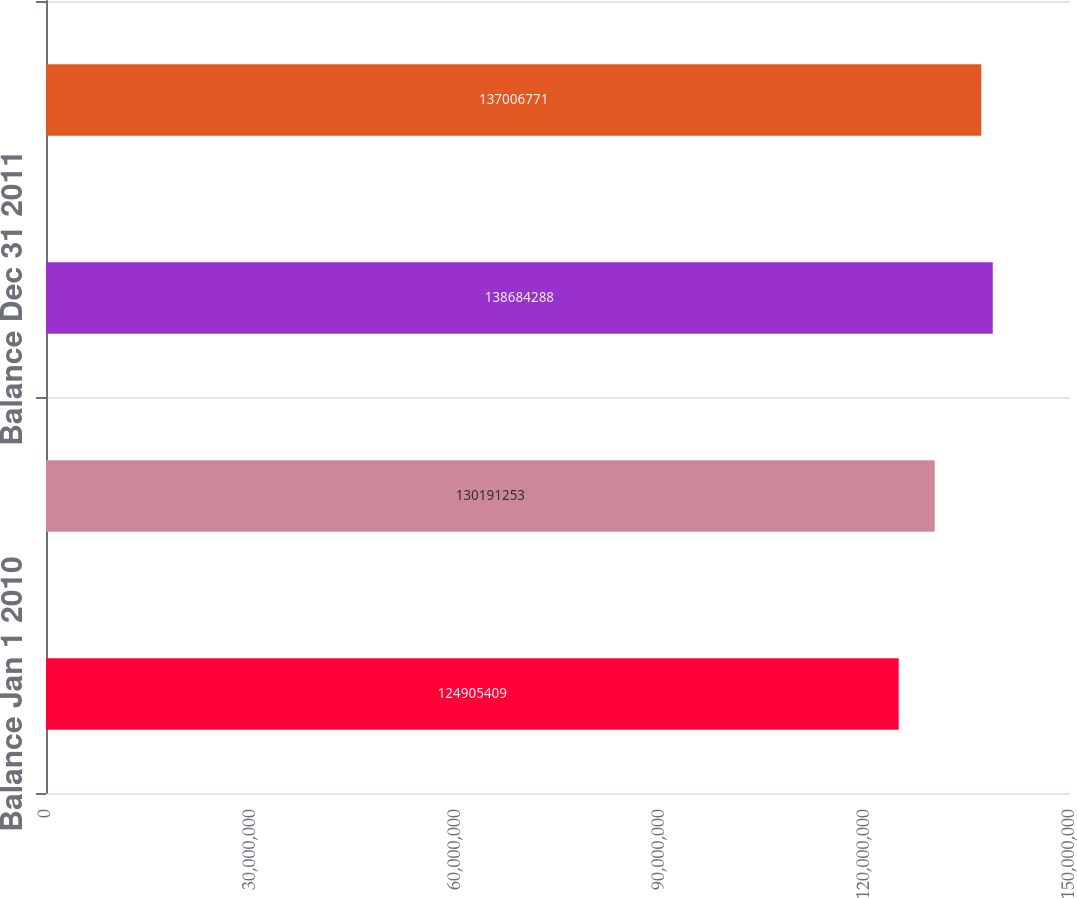Convert chart to OTSL. <chart><loc_0><loc_0><loc_500><loc_500><bar_chart><fcel>Balance Jan 1 2010<fcel>Balance Dec 31 2010<fcel>Balance Dec 31 2011<fcel>Balance Dec 31 2012<nl><fcel>1.24905e+08<fcel>1.30191e+08<fcel>1.38684e+08<fcel>1.37007e+08<nl></chart> 